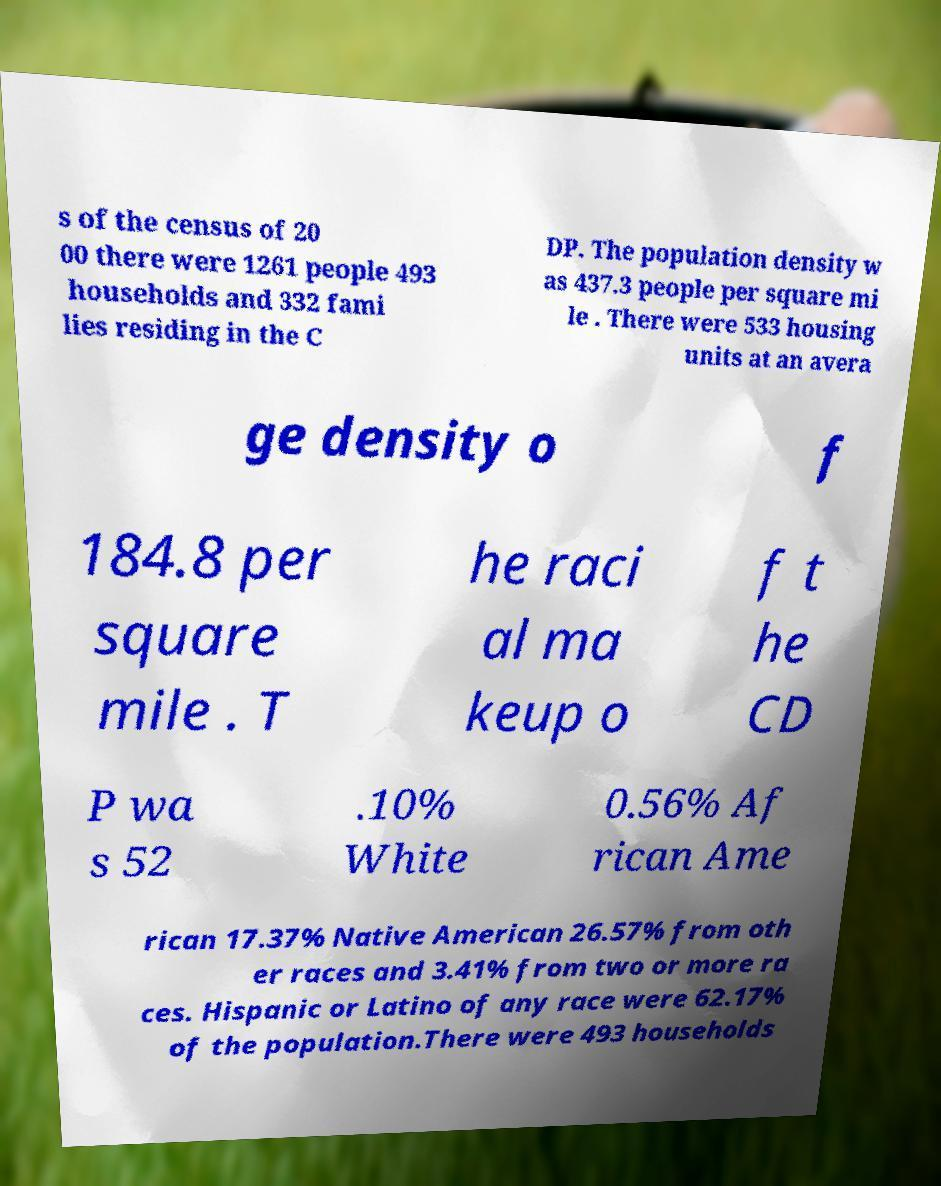Can you accurately transcribe the text from the provided image for me? s of the census of 20 00 there were 1261 people 493 households and 332 fami lies residing in the C DP. The population density w as 437.3 people per square mi le . There were 533 housing units at an avera ge density o f 184.8 per square mile . T he raci al ma keup o f t he CD P wa s 52 .10% White 0.56% Af rican Ame rican 17.37% Native American 26.57% from oth er races and 3.41% from two or more ra ces. Hispanic or Latino of any race were 62.17% of the population.There were 493 households 